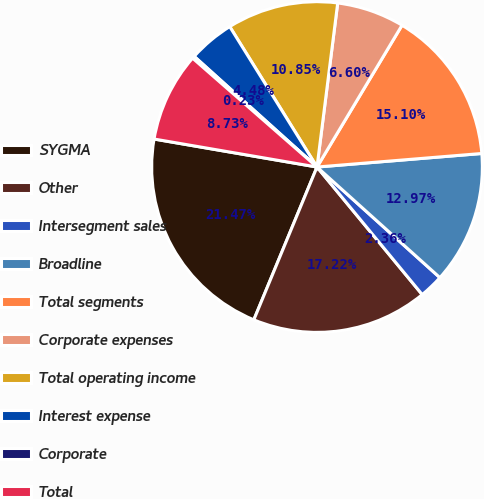<chart> <loc_0><loc_0><loc_500><loc_500><pie_chart><fcel>SYGMA<fcel>Other<fcel>Intersegment sales<fcel>Broadline<fcel>Total segments<fcel>Corporate expenses<fcel>Total operating income<fcel>Interest expense<fcel>Corporate<fcel>Total<nl><fcel>21.47%<fcel>17.22%<fcel>2.36%<fcel>12.97%<fcel>15.1%<fcel>6.6%<fcel>10.85%<fcel>4.48%<fcel>0.23%<fcel>8.73%<nl></chart> 